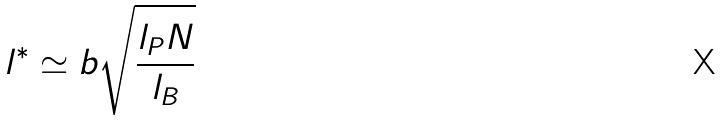<formula> <loc_0><loc_0><loc_500><loc_500>l ^ { * } \simeq b \sqrt { \frac { l _ { P } N } { l _ { B } } }</formula> 